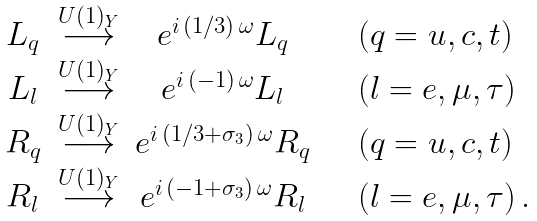Convert formula to latex. <formula><loc_0><loc_0><loc_500><loc_500>\begin{array} { c c c l } L _ { q } & \stackrel { U ( 1 ) _ { Y } } { \longrightarrow } & e ^ { i \, ( 1 / 3 ) \, \omega } L _ { q } & \quad ( q = u , c , t ) \\ L _ { l } & \stackrel { U ( 1 ) _ { Y } } { \longrightarrow } & e ^ { i \, ( - 1 ) \, \omega } L _ { l } & \quad ( l = e , \mu , \tau ) \\ R _ { q } & \stackrel { U ( 1 ) _ { Y } } { \longrightarrow } & e ^ { i \, ( 1 / 3 + \sigma _ { 3 } ) \, \omega } R _ { q } & \quad ( q = u , c , t ) \\ R _ { l } & \stackrel { U ( 1 ) _ { Y } } { \longrightarrow } & e ^ { i \, ( - 1 + \sigma _ { 3 } ) \, \omega } R _ { l } & \quad ( l = e , \mu , \tau ) \, . \end{array}</formula> 